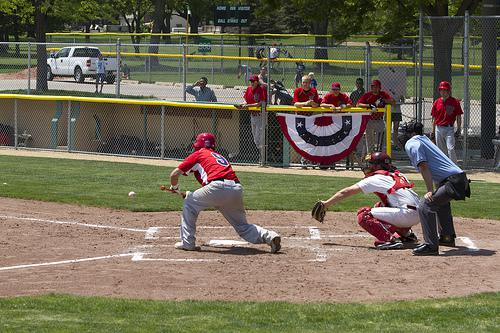Question: who is in the photo?
Choices:
A. People.
B. Family.
C. Boy scouts.
D. Bride and groom.
Answer with the letter. Answer: A Question: where was this photo taken?
Choices:
A. Tennis court.
B. At a baseball field.
C. Ice rink.
D. Skate park.
Answer with the letter. Answer: B Question: why are they in uniform?
Choices:
A. For work.
B. In military.
C. For school.
D. It's a team.
Answer with the letter. Answer: D Question: how is the photo?
Choices:
A. Blurry.
B. Unclear.
C. Clear.
D. Over-exposed.
Answer with the letter. Answer: C Question: what color are they wearing?
Choices:
A. Red.
B. Yellow.
C. White.
D. Black.
Answer with the letter. Answer: A Question: what sport is this?
Choices:
A. Basketball.
B. Racquetball.
C. Baseball.
D. Wrestling.
Answer with the letter. Answer: C 